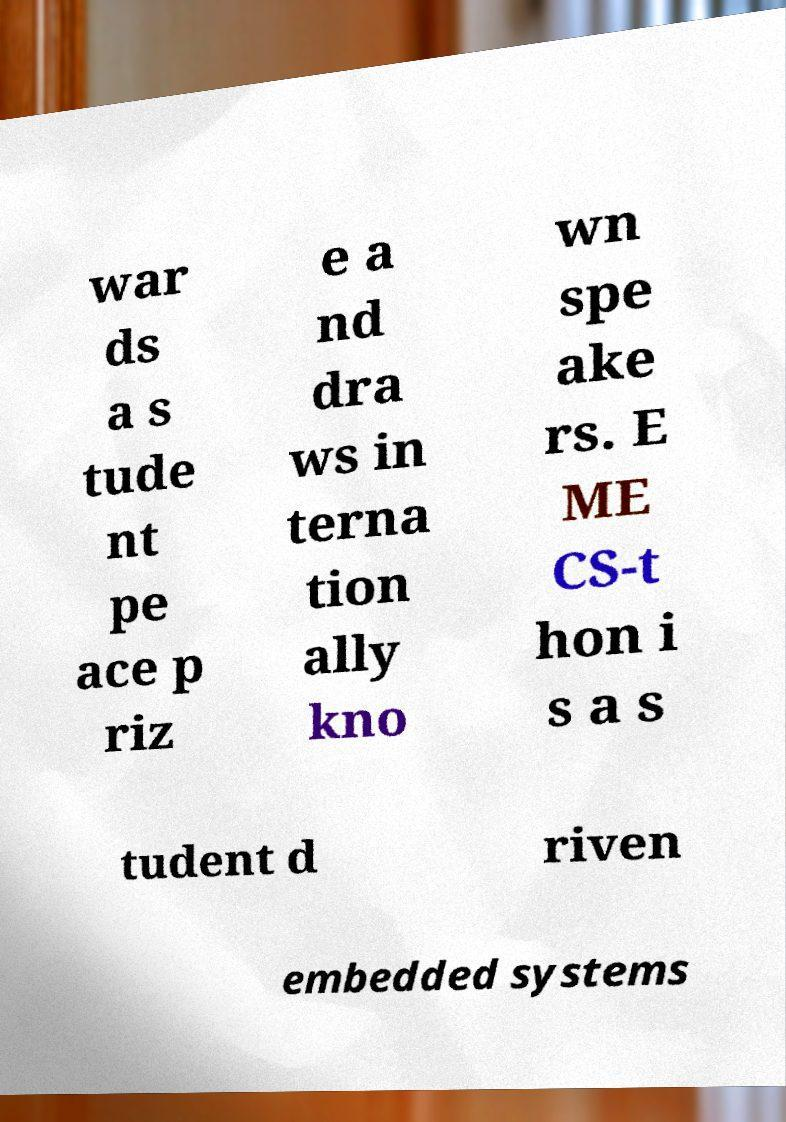Could you extract and type out the text from this image? war ds a s tude nt pe ace p riz e a nd dra ws in terna tion ally kno wn spe ake rs. E ME CS-t hon i s a s tudent d riven embedded systems 